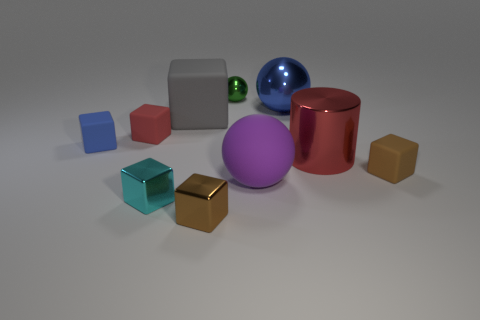Subtract all red spheres. How many brown blocks are left? 2 Subtract all big spheres. How many spheres are left? 1 Subtract all blue blocks. How many blocks are left? 5 Subtract 2 blocks. How many blocks are left? 4 Subtract all balls. How many objects are left? 7 Subtract all brown blocks. Subtract all purple cylinders. How many blocks are left? 4 Add 4 large metal cylinders. How many large metal cylinders are left? 5 Add 9 cyan blocks. How many cyan blocks exist? 10 Subtract 0 green blocks. How many objects are left? 10 Subtract all brown metal spheres. Subtract all matte balls. How many objects are left? 9 